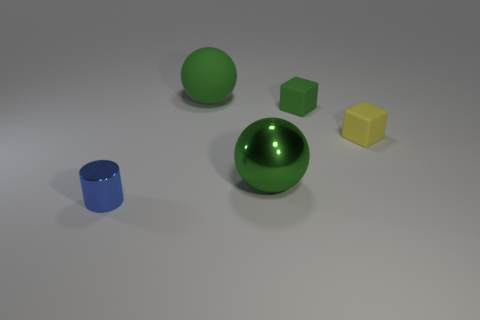There is a big ball that is right of the large green matte thing; is it the same color as the cylinder? No, the big ball on the right of the large green object, which appears to have a matte finish, is not the same color as the cylinder. The cylinder is blue, whereas the ball is green with a reflective surface that suggests a glossy finish. 